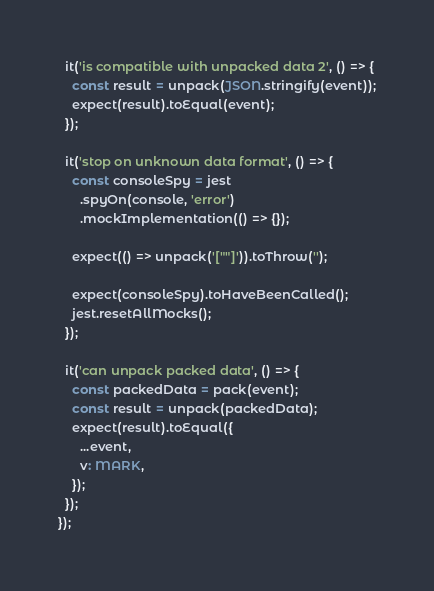<code> <loc_0><loc_0><loc_500><loc_500><_TypeScript_>  it('is compatible with unpacked data 2', () => {
    const result = unpack(JSON.stringify(event));
    expect(result).toEqual(event);
  });

  it('stop on unknown data format', () => {
    const consoleSpy = jest
      .spyOn(console, 'error')
      .mockImplementation(() => {});

    expect(() => unpack('[""]')).toThrow('');

    expect(consoleSpy).toHaveBeenCalled();
    jest.resetAllMocks();
  });

  it('can unpack packed data', () => {
    const packedData = pack(event);
    const result = unpack(packedData);
    expect(result).toEqual({
      ...event,
      v: MARK,
    });
  });
});
</code> 